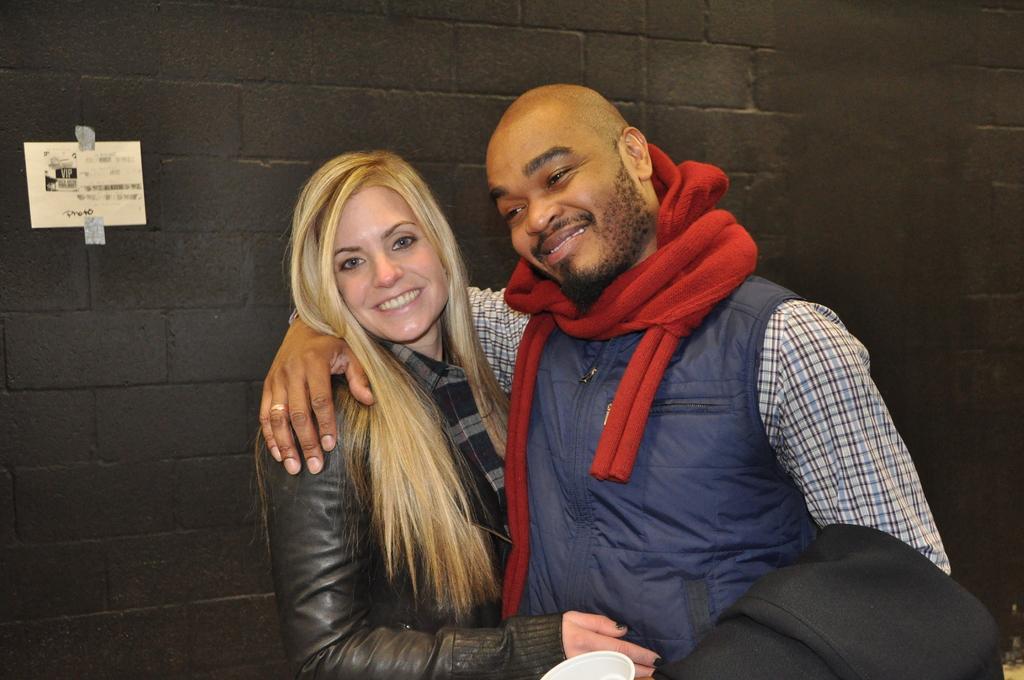Please provide a concise description of this image. In this image, there are two people standing. In the background, we can see the wall with a poster. 